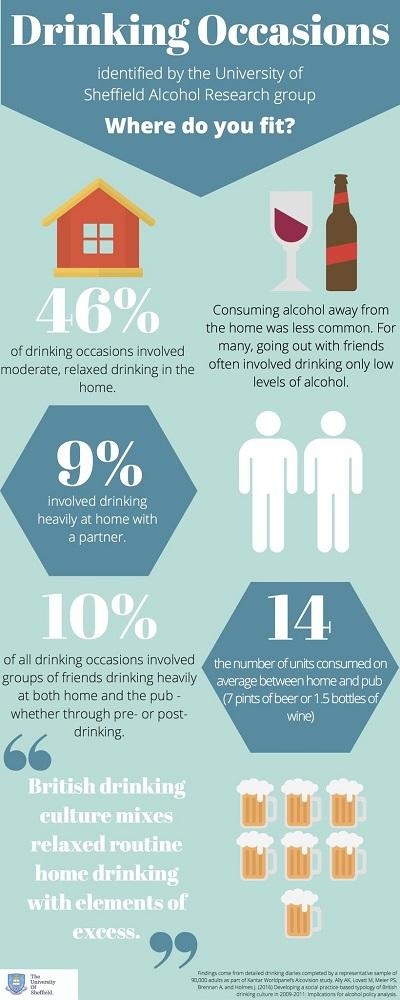Mention a couple of crucial points in this snapshot. In the infographic image, 7 beer mugs are visually depicted. 